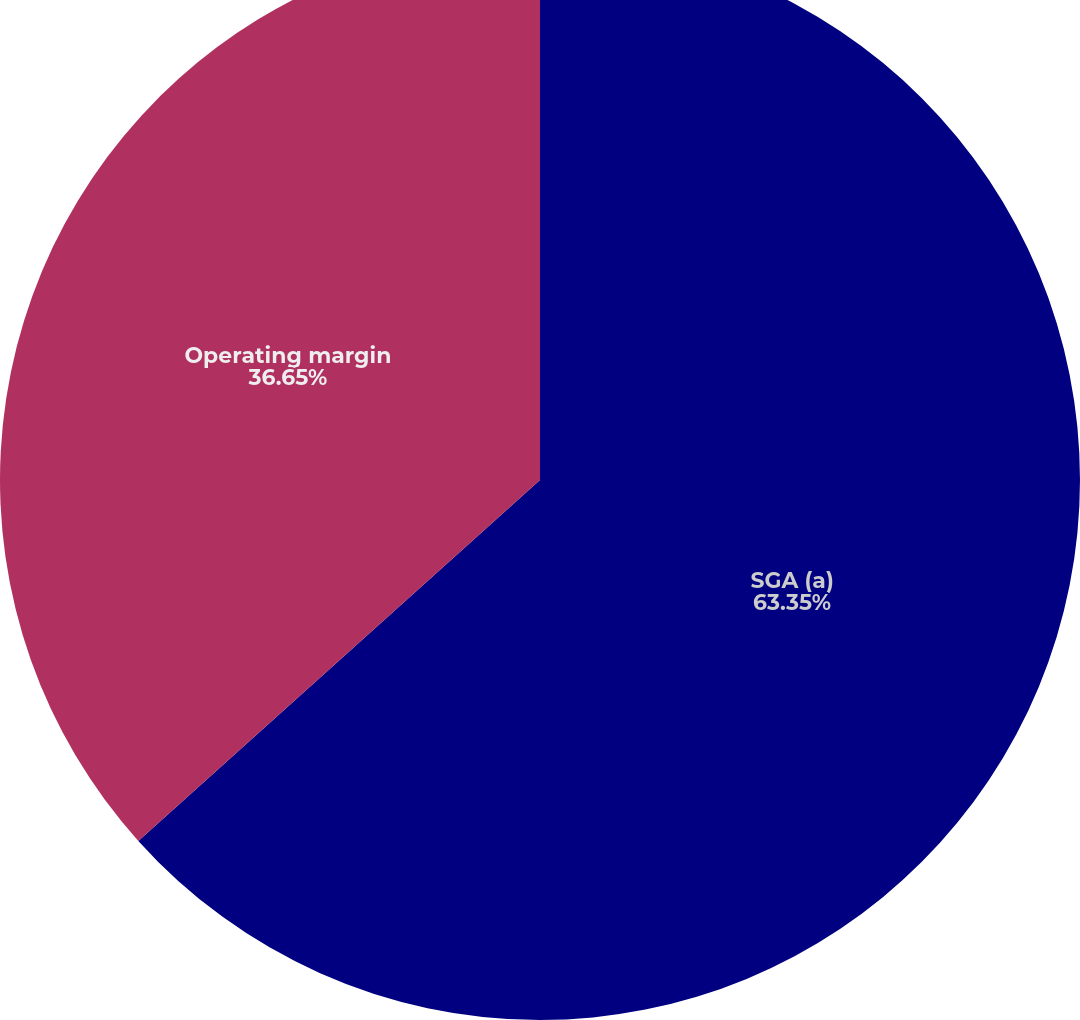Convert chart. <chart><loc_0><loc_0><loc_500><loc_500><pie_chart><fcel>SGA (a)<fcel>Operating margin<nl><fcel>63.35%<fcel>36.65%<nl></chart> 